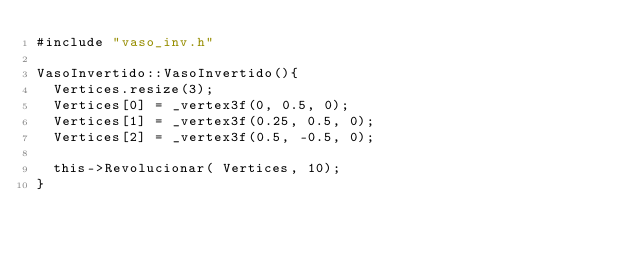Convert code to text. <code><loc_0><loc_0><loc_500><loc_500><_C++_>#include "vaso_inv.h"

VasoInvertido::VasoInvertido(){
	Vertices.resize(3);
	Vertices[0] = _vertex3f(0, 0.5, 0);
	Vertices[1] = _vertex3f(0.25, 0.5, 0);
	Vertices[2] = _vertex3f(0.5, -0.5, 0);

	this->Revolucionar( Vertices, 10);
}
</code> 